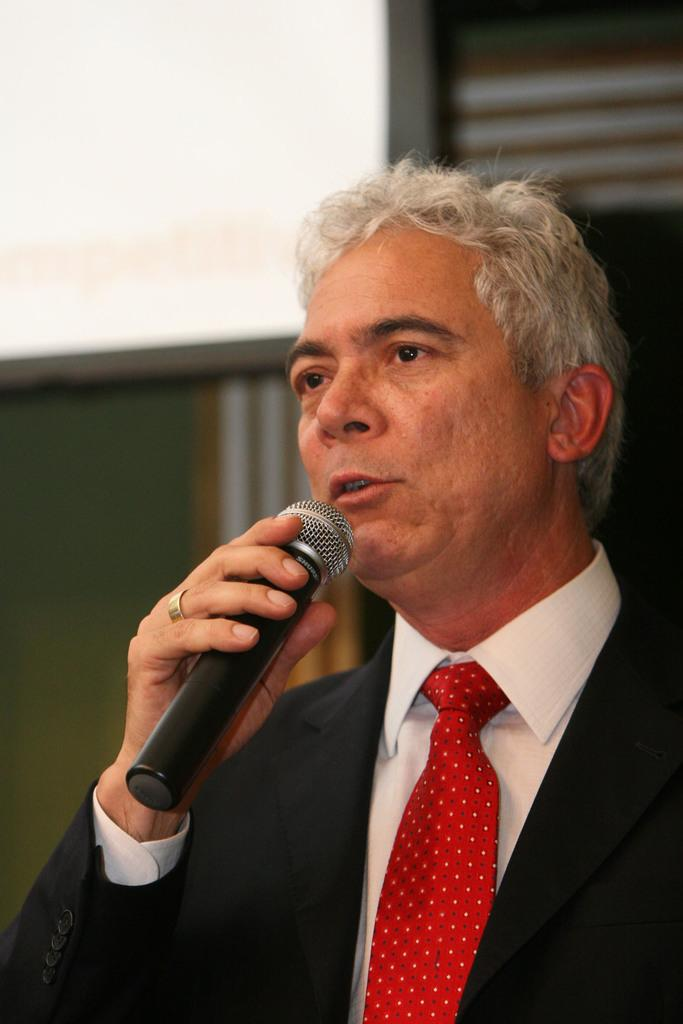What is the main subject of the image? There is a man in the image. What is the man doing in the image? The man is standing and talking into a microphone. What is the man holding in the image? The man is holding a microphone. What can be seen in the background of the image? There is a white color wall in the background of the image. What type of dinner is being served on the feather in the image? There is no dinner or feather present in the image. What is the reason for the man's speech in the image? The facts provided do not mention the reason for the man's speech, so we cannot determine the reason from the image alone. 